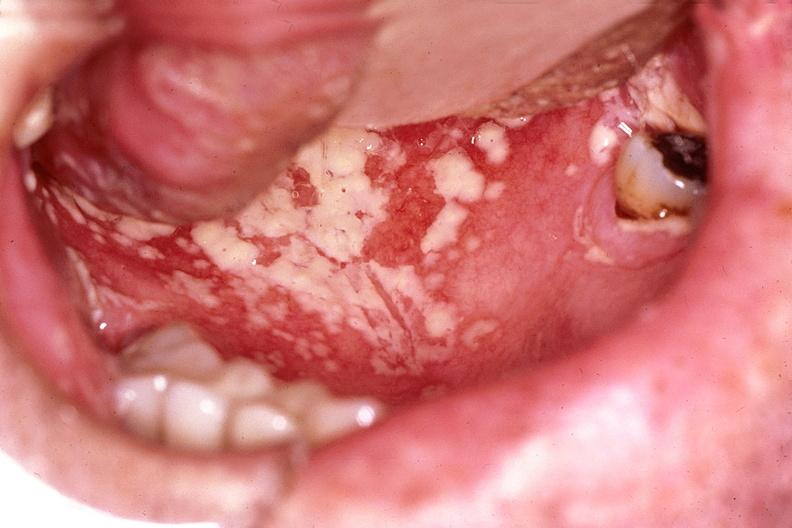does this image show mouth, candida, thrush?
Answer the question using a single word or phrase. Yes 